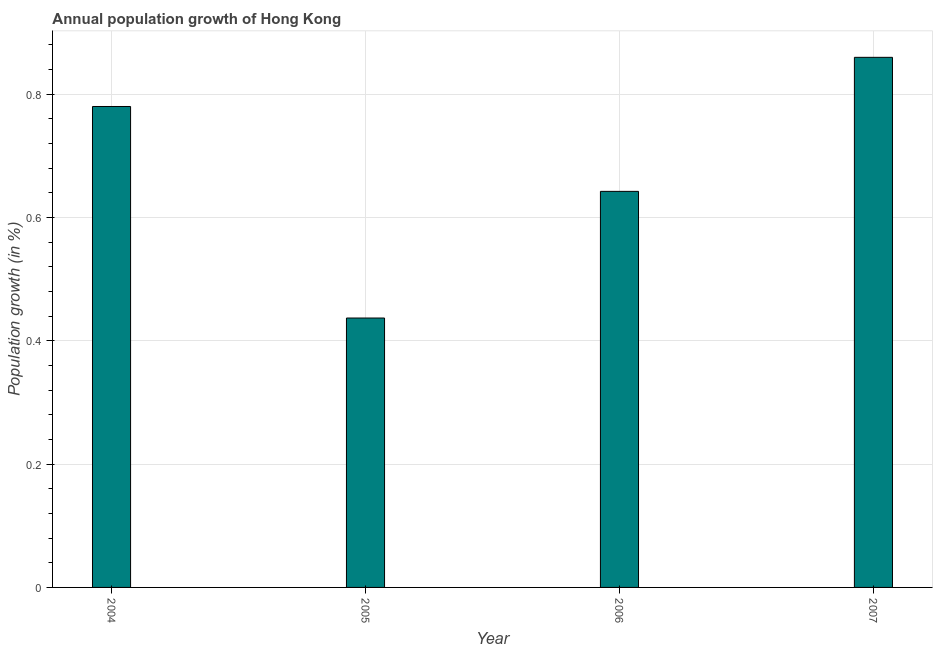Does the graph contain any zero values?
Your answer should be very brief. No. What is the title of the graph?
Give a very brief answer. Annual population growth of Hong Kong. What is the label or title of the X-axis?
Provide a succinct answer. Year. What is the label or title of the Y-axis?
Your answer should be compact. Population growth (in %). What is the population growth in 2006?
Offer a very short reply. 0.64. Across all years, what is the maximum population growth?
Make the answer very short. 0.86. Across all years, what is the minimum population growth?
Your answer should be very brief. 0.44. What is the sum of the population growth?
Provide a succinct answer. 2.72. What is the difference between the population growth in 2005 and 2006?
Offer a very short reply. -0.2. What is the average population growth per year?
Your response must be concise. 0.68. What is the median population growth?
Offer a terse response. 0.71. In how many years, is the population growth greater than 0.44 %?
Provide a succinct answer. 3. What is the ratio of the population growth in 2005 to that in 2006?
Give a very brief answer. 0.68. Is the population growth in 2005 less than that in 2007?
Keep it short and to the point. Yes. What is the difference between the highest and the second highest population growth?
Your answer should be compact. 0.08. Is the sum of the population growth in 2004 and 2007 greater than the maximum population growth across all years?
Make the answer very short. Yes. What is the difference between the highest and the lowest population growth?
Offer a terse response. 0.42. How many bars are there?
Keep it short and to the point. 4. What is the difference between two consecutive major ticks on the Y-axis?
Offer a very short reply. 0.2. What is the Population growth (in %) in 2004?
Give a very brief answer. 0.78. What is the Population growth (in %) of 2005?
Give a very brief answer. 0.44. What is the Population growth (in %) in 2006?
Provide a succinct answer. 0.64. What is the Population growth (in %) in 2007?
Make the answer very short. 0.86. What is the difference between the Population growth (in %) in 2004 and 2005?
Offer a terse response. 0.34. What is the difference between the Population growth (in %) in 2004 and 2006?
Ensure brevity in your answer.  0.14. What is the difference between the Population growth (in %) in 2004 and 2007?
Ensure brevity in your answer.  -0.08. What is the difference between the Population growth (in %) in 2005 and 2006?
Keep it short and to the point. -0.21. What is the difference between the Population growth (in %) in 2005 and 2007?
Ensure brevity in your answer.  -0.42. What is the difference between the Population growth (in %) in 2006 and 2007?
Provide a short and direct response. -0.22. What is the ratio of the Population growth (in %) in 2004 to that in 2005?
Offer a terse response. 1.78. What is the ratio of the Population growth (in %) in 2004 to that in 2006?
Provide a short and direct response. 1.21. What is the ratio of the Population growth (in %) in 2004 to that in 2007?
Give a very brief answer. 0.91. What is the ratio of the Population growth (in %) in 2005 to that in 2006?
Ensure brevity in your answer.  0.68. What is the ratio of the Population growth (in %) in 2005 to that in 2007?
Your answer should be very brief. 0.51. What is the ratio of the Population growth (in %) in 2006 to that in 2007?
Your answer should be very brief. 0.75. 